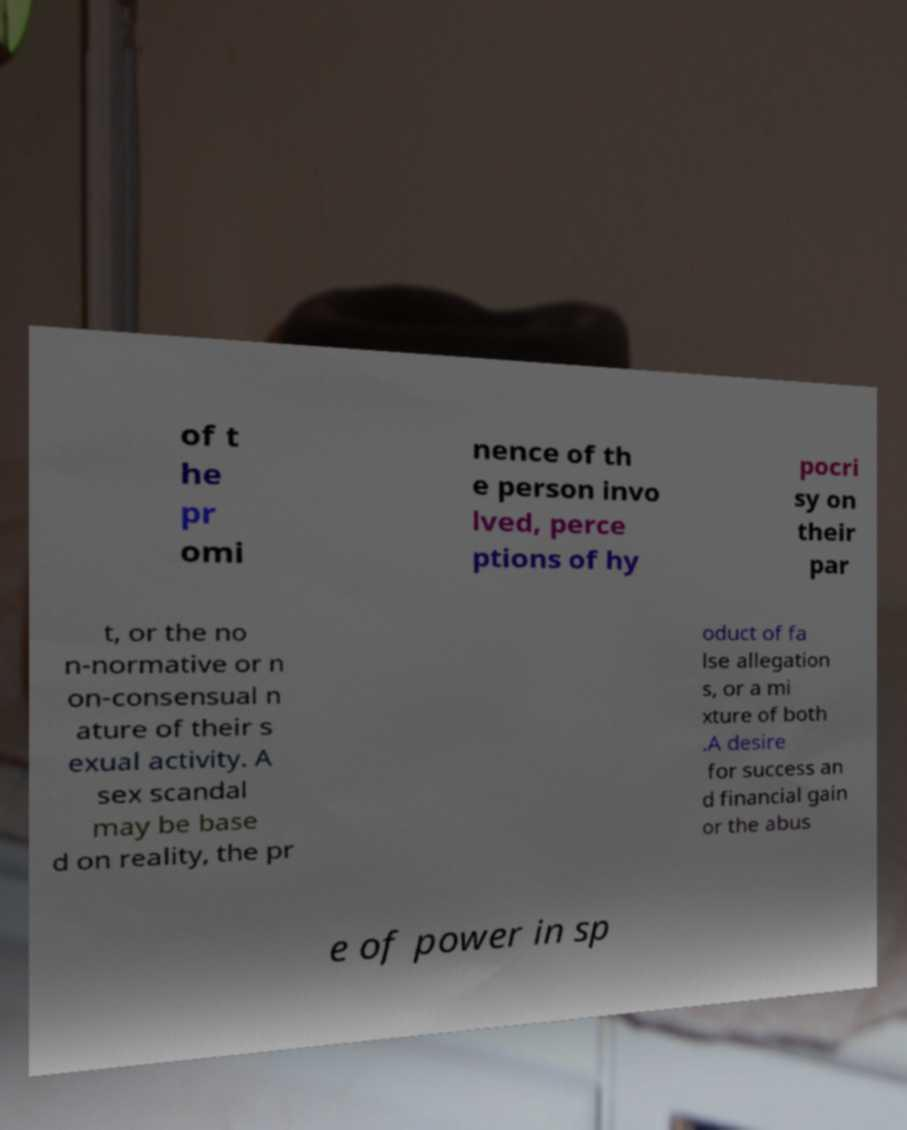What messages or text are displayed in this image? I need them in a readable, typed format. of t he pr omi nence of th e person invo lved, perce ptions of hy pocri sy on their par t, or the no n-normative or n on-consensual n ature of their s exual activity. A sex scandal may be base d on reality, the pr oduct of fa lse allegation s, or a mi xture of both .A desire for success an d financial gain or the abus e of power in sp 